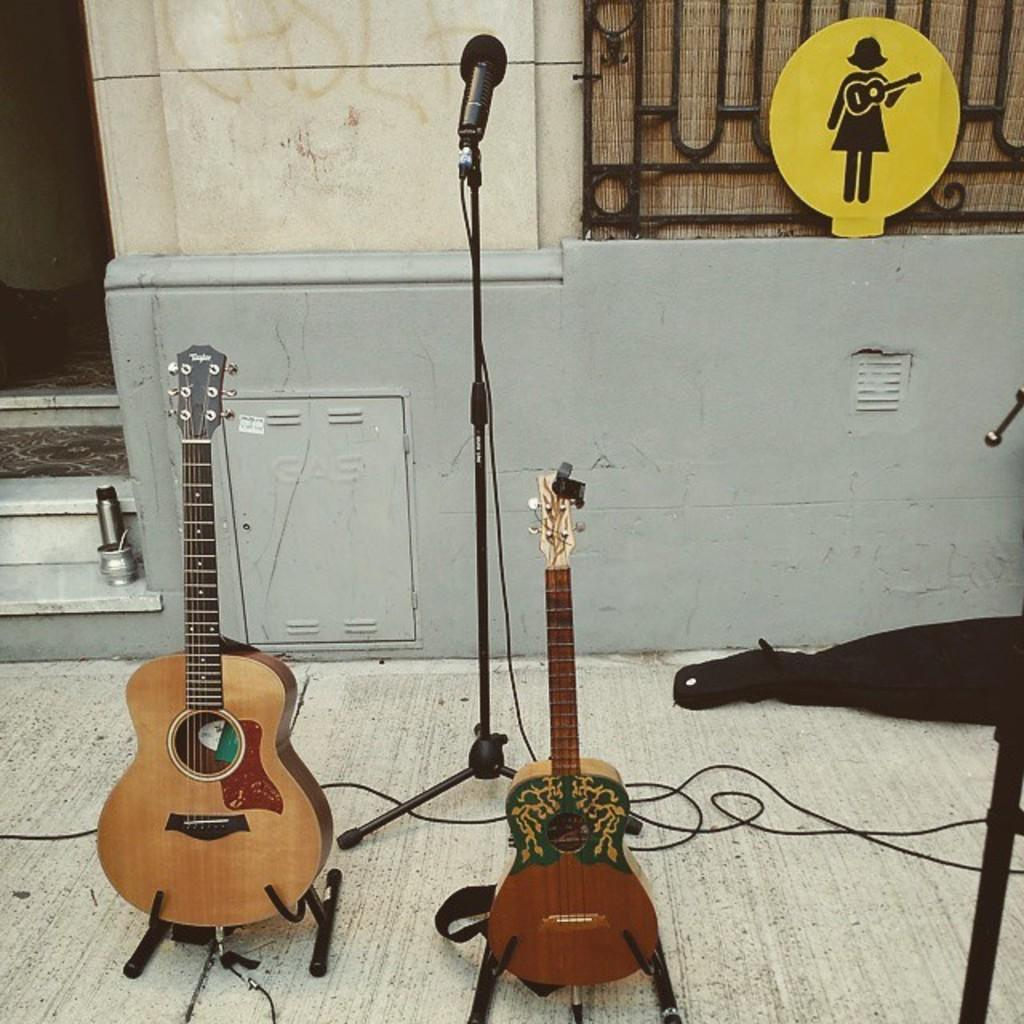What is the main object in the image? There is a sign board in the image. What equipment is present for audio purposes? There is a mic with a mic holder in the image. What musical instruments can be seen on the floor? There are guitars on the floor in the image. What type of bag is visible in the image? There is a bag in the image. What else can be found on the floor besides the guitars? There are cables on the floor in the image. Are there any architectural features in the image? Yes, there are steps in the image. How many bikes are parked near the steps in the image? There are no bikes present in the image. What is the self-imposed limit on the number of guitars in the image? There is no self-imposed limit mentioned in the image, and there are no guitars in the image. 